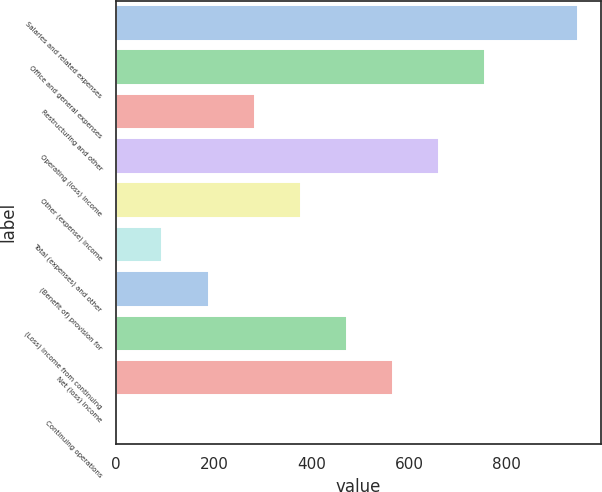Convert chart. <chart><loc_0><loc_0><loc_500><loc_500><bar_chart><fcel>Salaries and related expenses<fcel>Office and general expenses<fcel>Restructuring and other<fcel>Operating (loss) income<fcel>Other (expense) income<fcel>Total (expenses) and other<fcel>(Benefit of) provision for<fcel>(Loss) income from continuing<fcel>Net (loss) income<fcel>Continuing operations<nl><fcel>945.1<fcel>756.1<fcel>283.6<fcel>661.6<fcel>378.1<fcel>94.6<fcel>189.1<fcel>472.6<fcel>567.1<fcel>0.1<nl></chart> 